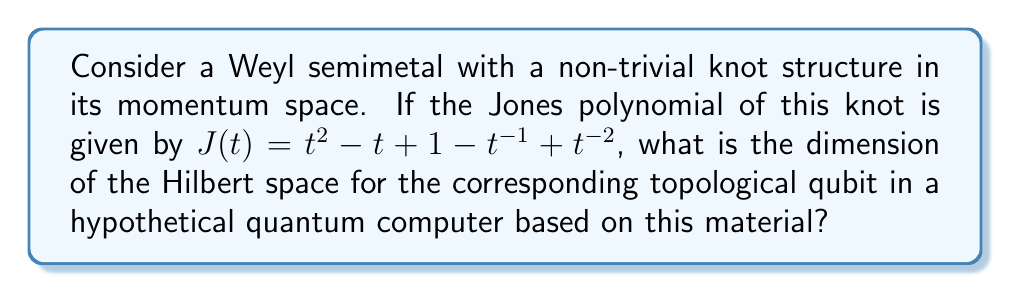Provide a solution to this math problem. To solve this problem, we need to follow these steps:

1) The Jones polynomial is a knot invariant that has deep connections to topological quantum field theory and, by extension, topological quantum computing.

2) In topological quantum computing, the dimension of the Hilbert space for a qubit is related to the number of distinct anyon types in the system. For knots, this is connected to the number of terms in the Jones polynomial.

3) The Jones polynomial given is:

   $J(t) = t^2 - t + 1 - t^{-1} + t^{-2}$

4) Count the number of terms in the polynomial:
   - $t^2$
   - $-t$
   - $1$
   - $-t^{-1}$
   - $t^{-2}$

   There are 5 terms in total.

5) In topological quantum computing based on knot theory, each term in the Jones polynomial corresponds to a distinct anyon type.

6) The dimension of the Hilbert space is given by $2^n$, where $n$ is the number of qubits. In this case, we need to find $n$ such that $2^n$ is greater than or equal to the number of anyon types (terms in the Jones polynomial).

7) The smallest $n$ that satisfies this is 3, because:
   $2^2 = 4 < 5$
   $2^3 = 8 > 5$

Therefore, the dimension of the Hilbert space is $2^3 = 8$.
Answer: 8 